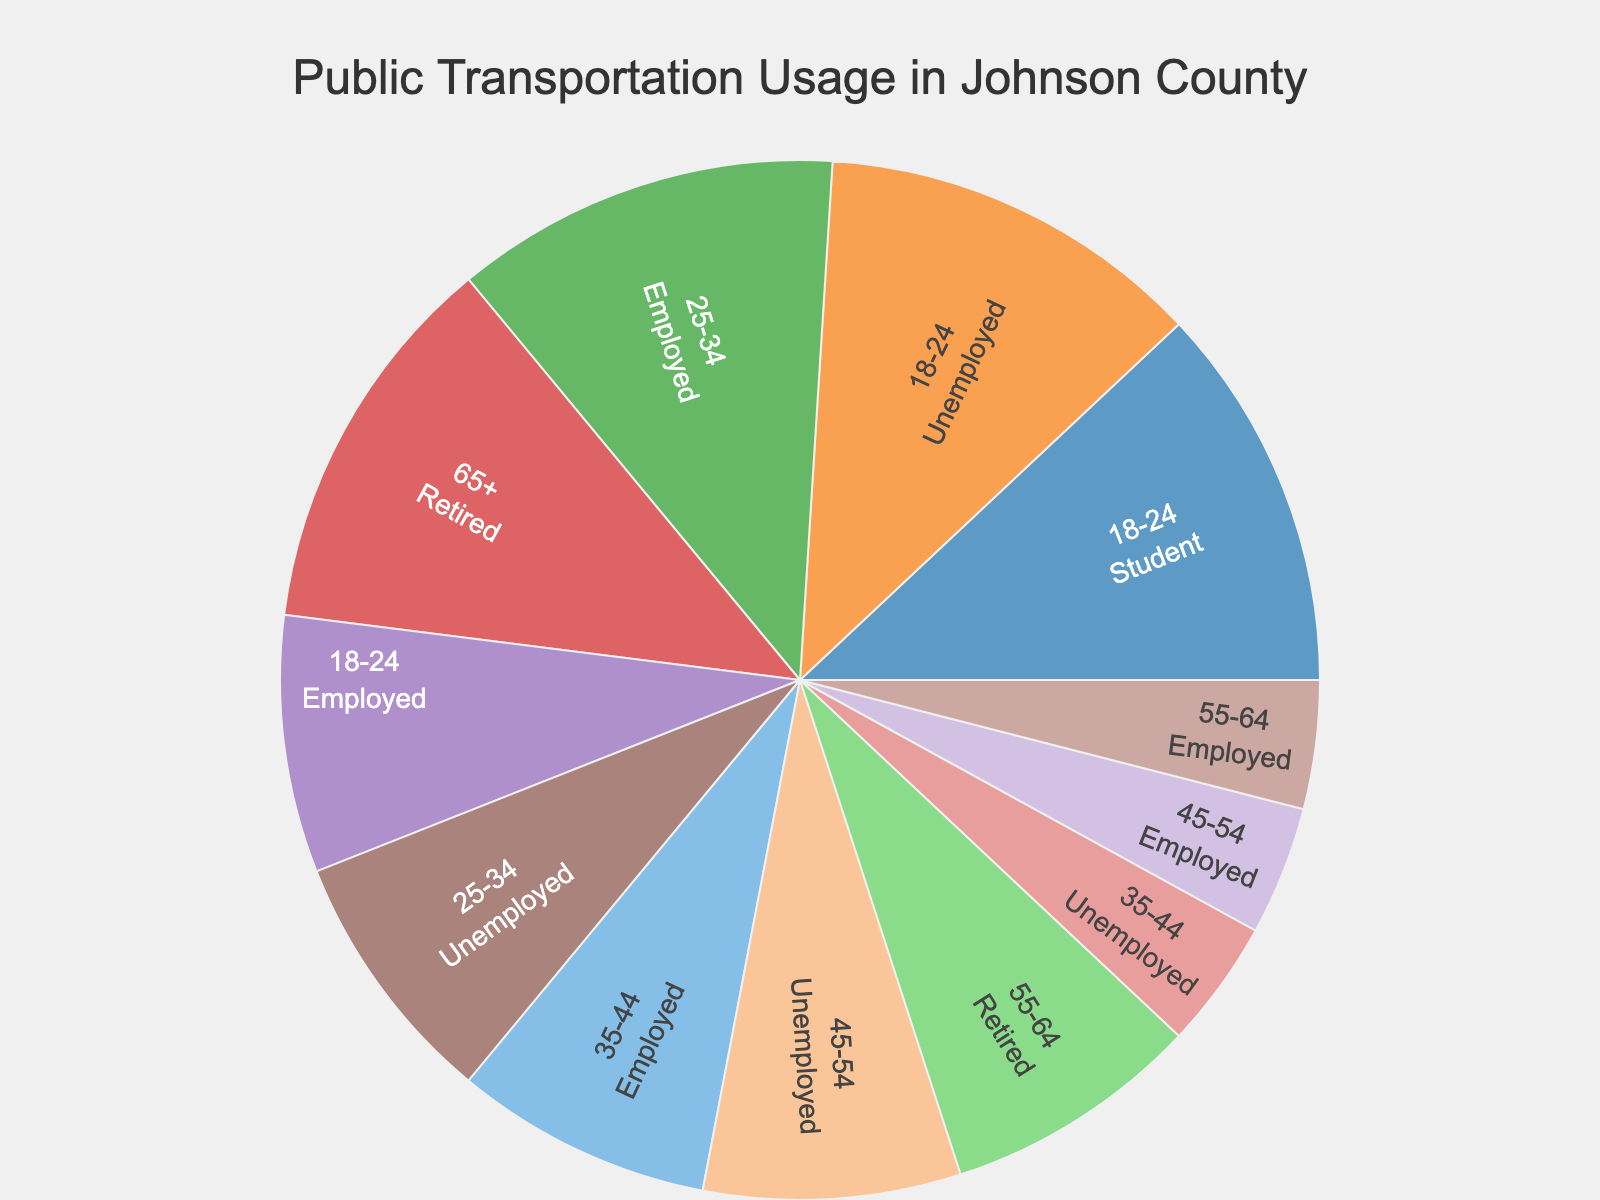What is the title of the plot? The title is typically displayed at the top of the plot. In this case, it is "Public Transportation Usage in Johnson County".
Answer: Public Transportation Usage in Johnson County Which age group has the highest usage of public transportation? Check the labels with "High" usage frequency. The 18-24 age group (students and unemployed) and the 65+ retired group have "High" usage frequency.
Answer: 18-24, 65+ What is the employment status of 25-34 age group with the highest usage? Check the 25-34 age group and identify the employment status associated with "High" usage. "Employed" status is associated with "High" usage.
Answer: Employed How many employment statuses have "Medium" usage frequency for the age group 55-64? For the age group 55-64, check the employment status labels and count those marked with "Medium" usage frequency. Retired status has "Medium" usage for this age group.
Answer: 1 Compare the public transportation usage between employed individuals in the 35-44 and 45-54 age groups. Which group has higher usage? Check the "Employed" status for both age groups and compare their usage frequency. 35-44 is "Medium" and 45-54 is "Low". Therefore, 35-44 has higher usage.
Answer: 35-44 For which employment status is public transportation usage consistently below medium across different age groups? Check each age group for employment statuses with "Low" and "Medium" usage frequencies, excluding "High". Unemployed consistently has "Low" or "Medium" usage.
Answer: Unemployed Which age group has no representation in the "Low" usage frequency category? Check each age group and identify if any category lacks "Low" usage frequency. 18-24 and 65+ age groups have no representation in the "Low" category.
Answer: 18-24, 65+ Summarize the overall trend for public transportation usage regarding the retired individuals. Analyze the usage frequencies linked with the "Retired" status across applicable age groups. Both 55-64 (Medium) and 65+ (High) show medium to high usage.
Answer: Medium to High Which age group and employment status combination has the lowest usage frequency? Check each age group and its corresponding employment statuses for the "Low" usage frequency. Both 35-44 Unemployed, 45-54 Employed, and 55-64 Employed have "Low" usage, choose one for detailed response.
Answer: 55-64 Employed 